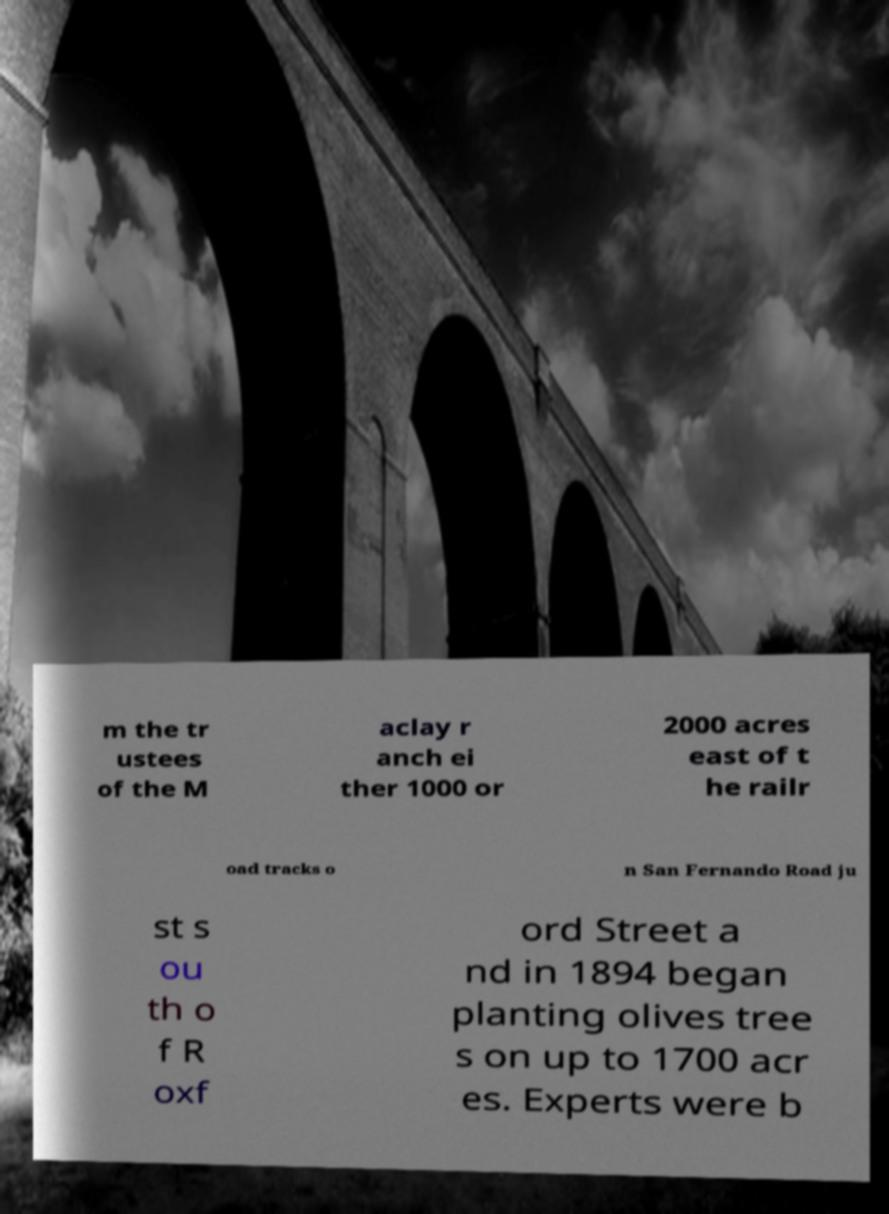Can you read and provide the text displayed in the image?This photo seems to have some interesting text. Can you extract and type it out for me? m the tr ustees of the M aclay r anch ei ther 1000 or 2000 acres east of t he railr oad tracks o n San Fernando Road ju st s ou th o f R oxf ord Street a nd in 1894 began planting olives tree s on up to 1700 acr es. Experts were b 